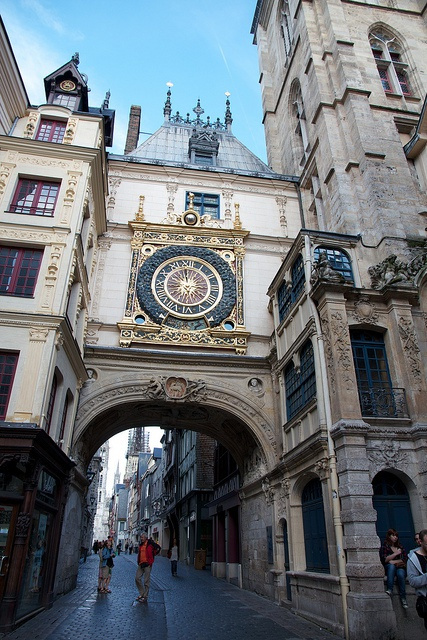Describe the objects in this image and their specific colors. I can see clock in lightblue, ivory, gray, darkgray, and tan tones, people in lightblue, black, gray, and navy tones, people in lightblue, black, gray, and blue tones, people in lightblue, black, maroon, and gray tones, and people in lightblue, black, gray, blue, and navy tones in this image. 